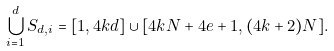Convert formula to latex. <formula><loc_0><loc_0><loc_500><loc_500>\bigcup _ { i = 1 } ^ { d } S _ { d , i } = [ 1 , 4 k d ] \cup [ 4 k N + 4 e + 1 , ( 4 k + 2 ) N ] .</formula> 